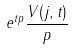<formula> <loc_0><loc_0><loc_500><loc_500>e ^ { t p } \frac { V ( j , t ) } { p }</formula> 